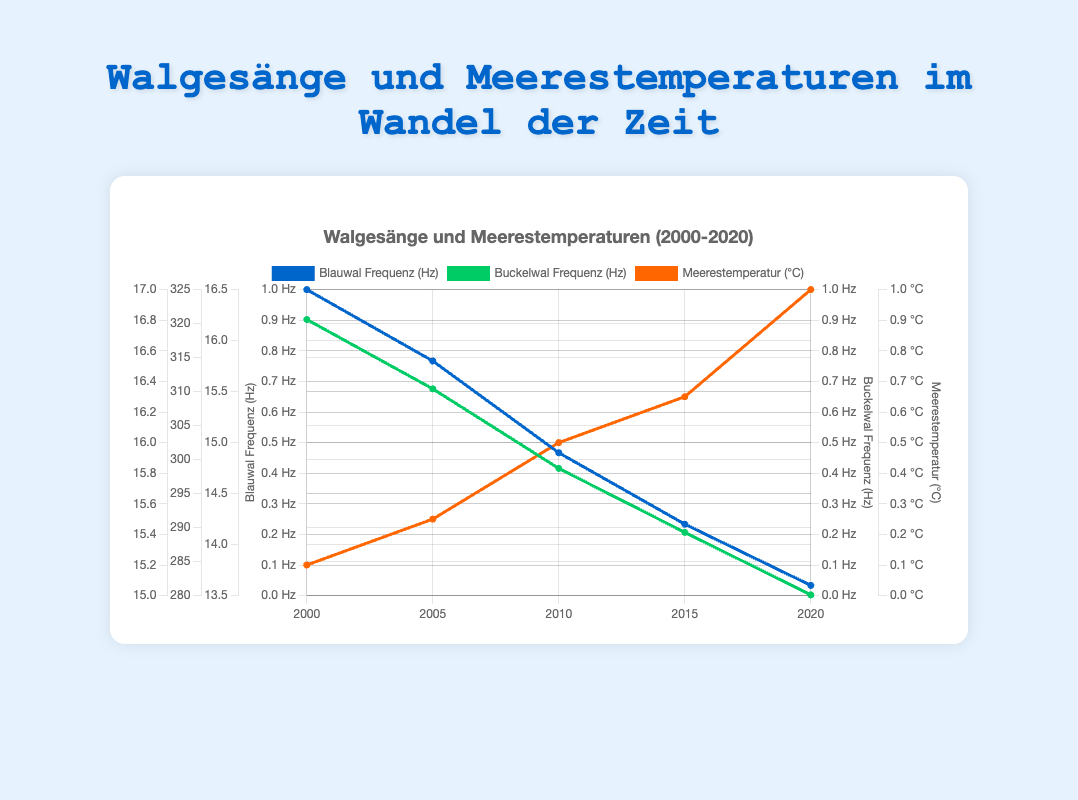Welcher Wal produziert die höchste Frequenz im Jahr 2020? Laut der Grafik erzeugt der Buckelwal im Jahr 2020 die höchste Frequenz. Die Frequenz des Buckelwals ist höher als die des Blauwals.
Answer: Buckelwal Wie hat sich die Frequenz der Blauwalgesänge von 2000 bis 2020 verändert? Die Frequenz der Blauwalgesänge nimmt von 16,5 Hz im Jahr 2000 auf 13,6 Hz im Jahr 2020 ab. Der Trend zeigt eine kontinuierliche Verringerung über die Jahre hinweg.
Answer: Abnahme Wie verhält sich die Meerestemperatur zwischen den Jahren 2000 und 2020? Die Meerestemperatur steigt von 15,2 °C im Jahr 2000 auf 17,0 °C im Jahr 2020. Das deutet auf eine allgemeine Erwärmung des Ozeans über die Jahre hin.
Answer: Steigt Vergleiche die Änderung der Frequenzen von Blau- und Buckelwalen zwischen 2010 und 2015. Zwischen 2010 und 2015 sinkt die Frequenz des Blauwals von 14,9 Hz auf 14,2 Hz, was eine Abnahme von 0,7 Hz darstellt. Die Frequenz des Buckelwals sinkt von 298,7 Hz auf 289,3 Hz, was eine Abnahme von 9,4 Hz bedeutet.
Answer: Die Frequenz des Buckelwals sinkt mehr Welcher Wal zeigte die größte Veränderung in der Frequenz zwischen 2000 und 2020? Blaue Wale zeigten eine Abnahme von 16,5 Hz auf 13,6 Hz, was eine Veränderung um 2,9 Hz ist. Buckelwale zeigten eine Abnahme von 320,6 Hz auf 280,1 Hz, was eine Veränderung um 40,5 Hz darstellt.
Answer: Buckelwal Welches Jahr zeigt den stärksten Rückgang der Frequenz für Blau- und Buckelwale? Der stärkste Rückgang für Blau- und Buckelwale erfolgt zwischen 2005 und 2010. Blauwale gehen von 15,8 Hz auf 14,9 Hz und Buckelwale von 310,4 Hz auf 298,7 Hz zurück. Diese Zeitspanne zeigt den stärksten Rückgang für beide Arten.
Answer: 2005 bis 2010 Vergleicht man die Meerestemperaturänderung mit der Änderung der Blauwal-Frequenzen, was lässt sich beobachten? Während die Meerestemperatur von 15,2 °C im Jahr 2000 auf 17,0 °C im Jahr 2020 ansteigt, nimmt die Frequenz der Blauwalgesänge von 16,5 Hz auf 13,6 Hz ab. Es gibt einen inversen Zusammenhang zwischen steigender Temperatur und sinkender Frequenz.
Answer: Inverser Zusammenhang 